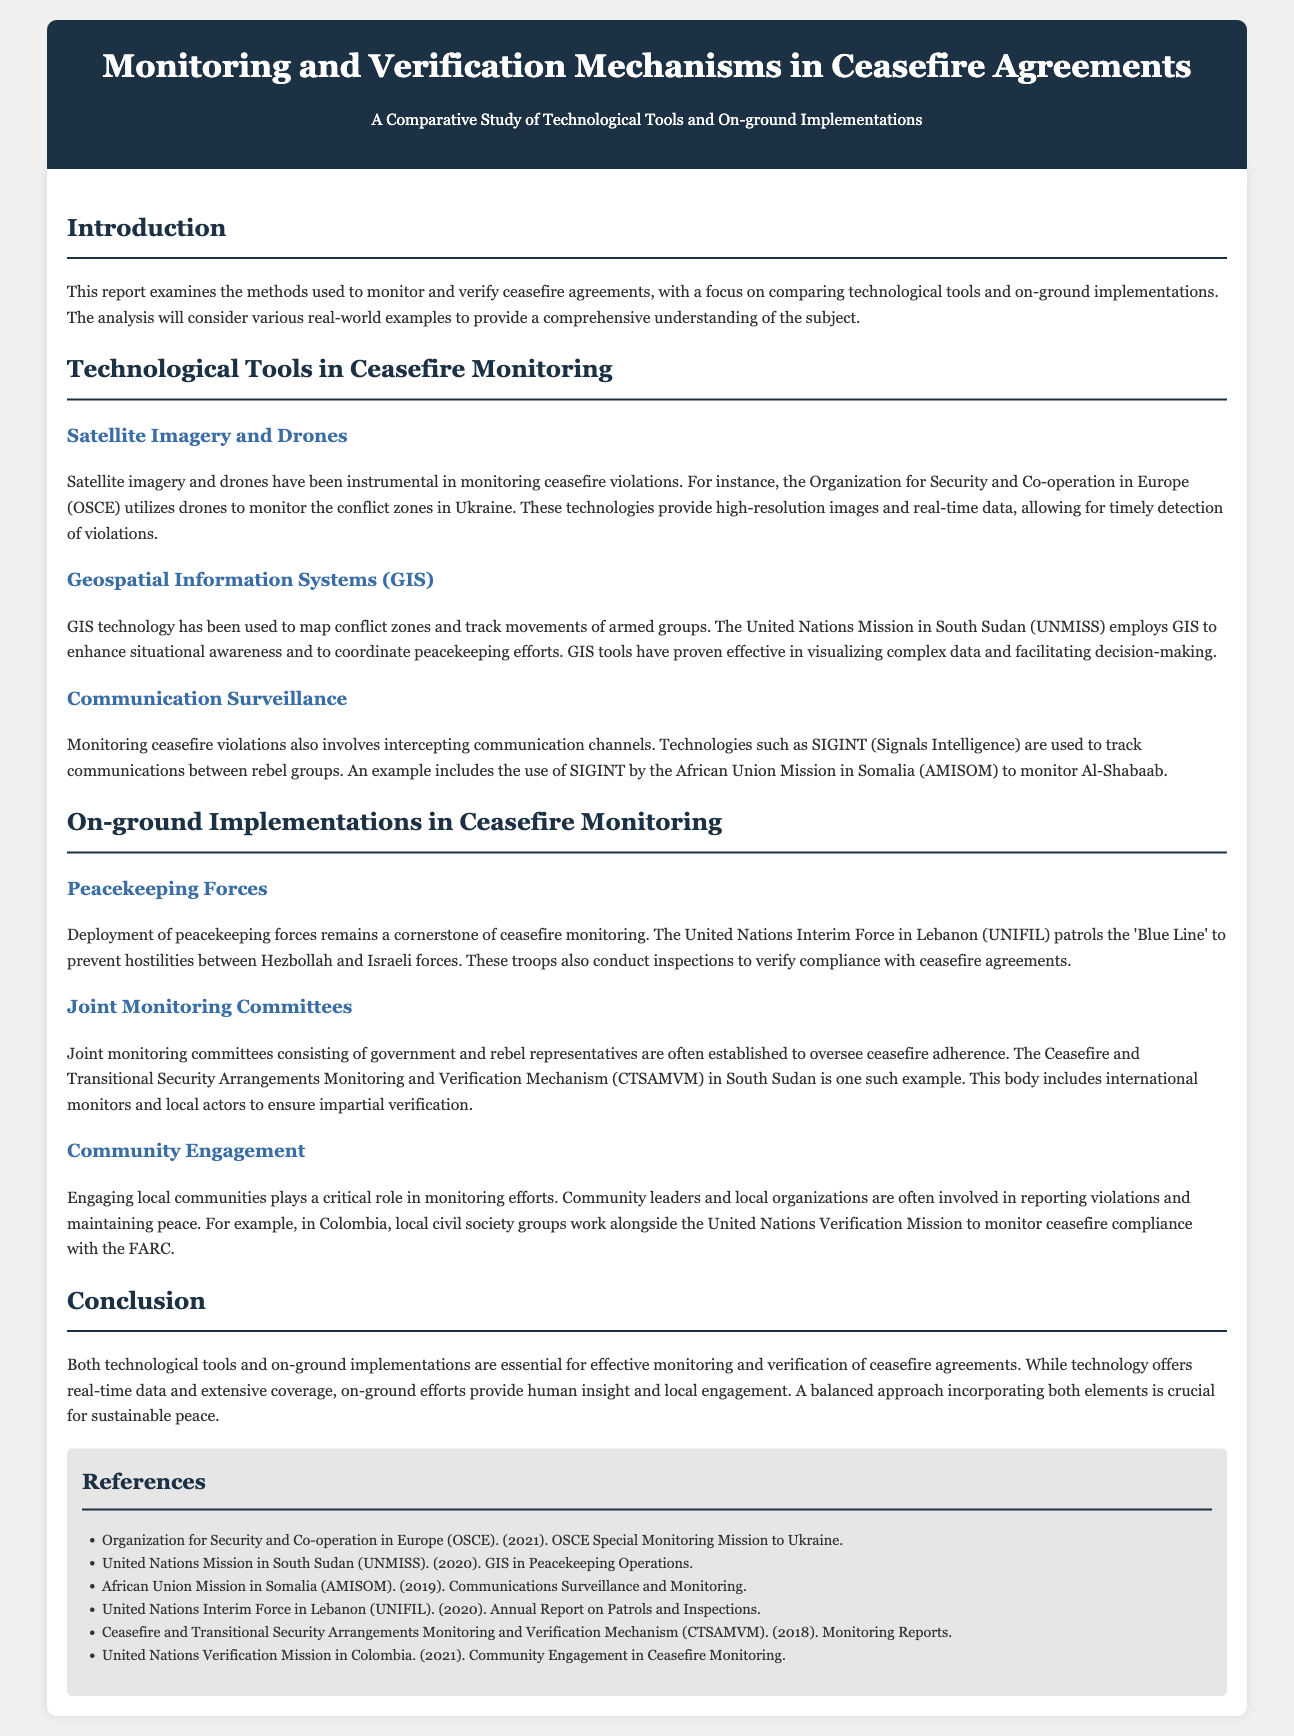what is the title of the report? The title of the report is stated in the header section of the document.
Answer: Monitoring and Verification Mechanisms in Ceasefire Agreements who uses drones to monitor conflict zones in Ukraine? The specific organization mentioned that uses drones for monitoring is included in the document.
Answer: Organization for Security and Co-operation in Europe (OSCE) what technology is used by UNMISS to enhance situational awareness? The report specifically mentions which technology enhances situational awareness for UNMISS.
Answer: Geospatial Information Systems (GIS) which monitoring mechanism involves government and rebel representatives? The report describes a specific mechanism involving representatives from both sides.
Answer: Joint Monitoring Committees what is the role of community leaders in monitoring efforts? The document provides information on how community leaders contribute to monitoring efforts.
Answer: Reporting violations which mission conducts patrols along the 'Blue Line'? The document mentions the name of the mission responsible for patrols along this specific line.
Answer: United Nations Interim Force in Lebanon (UNIFIL) what does CTSAMVM stand for? The full name of the abbreviation is provided in the document.
Answer: Ceasefire and Transitional Security Arrangements Monitoring and Verification Mechanism how many years of monitoring reports are cited for CTSAMVM? The document specifies the year of a report mentioned.
Answer: 2018 what is the main conclusion regarding the monitoring approaches? The conclusion summarizes the effectiveness of the different approaches discussed.
Answer: Balanced approach incorporating both elements is crucial for sustainable peace 